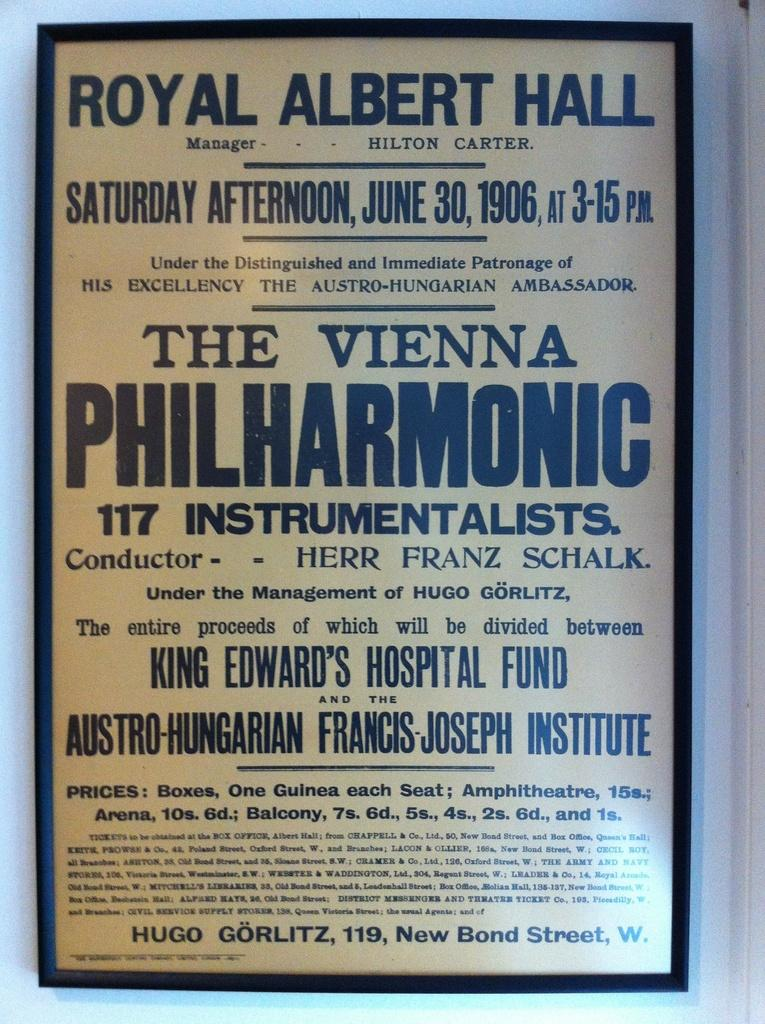<image>
Provide a brief description of the given image. A sign that has many words with PHILHARMONIC being the largest. 